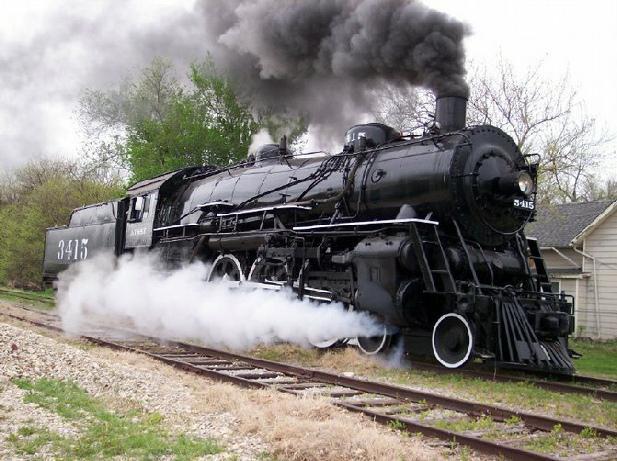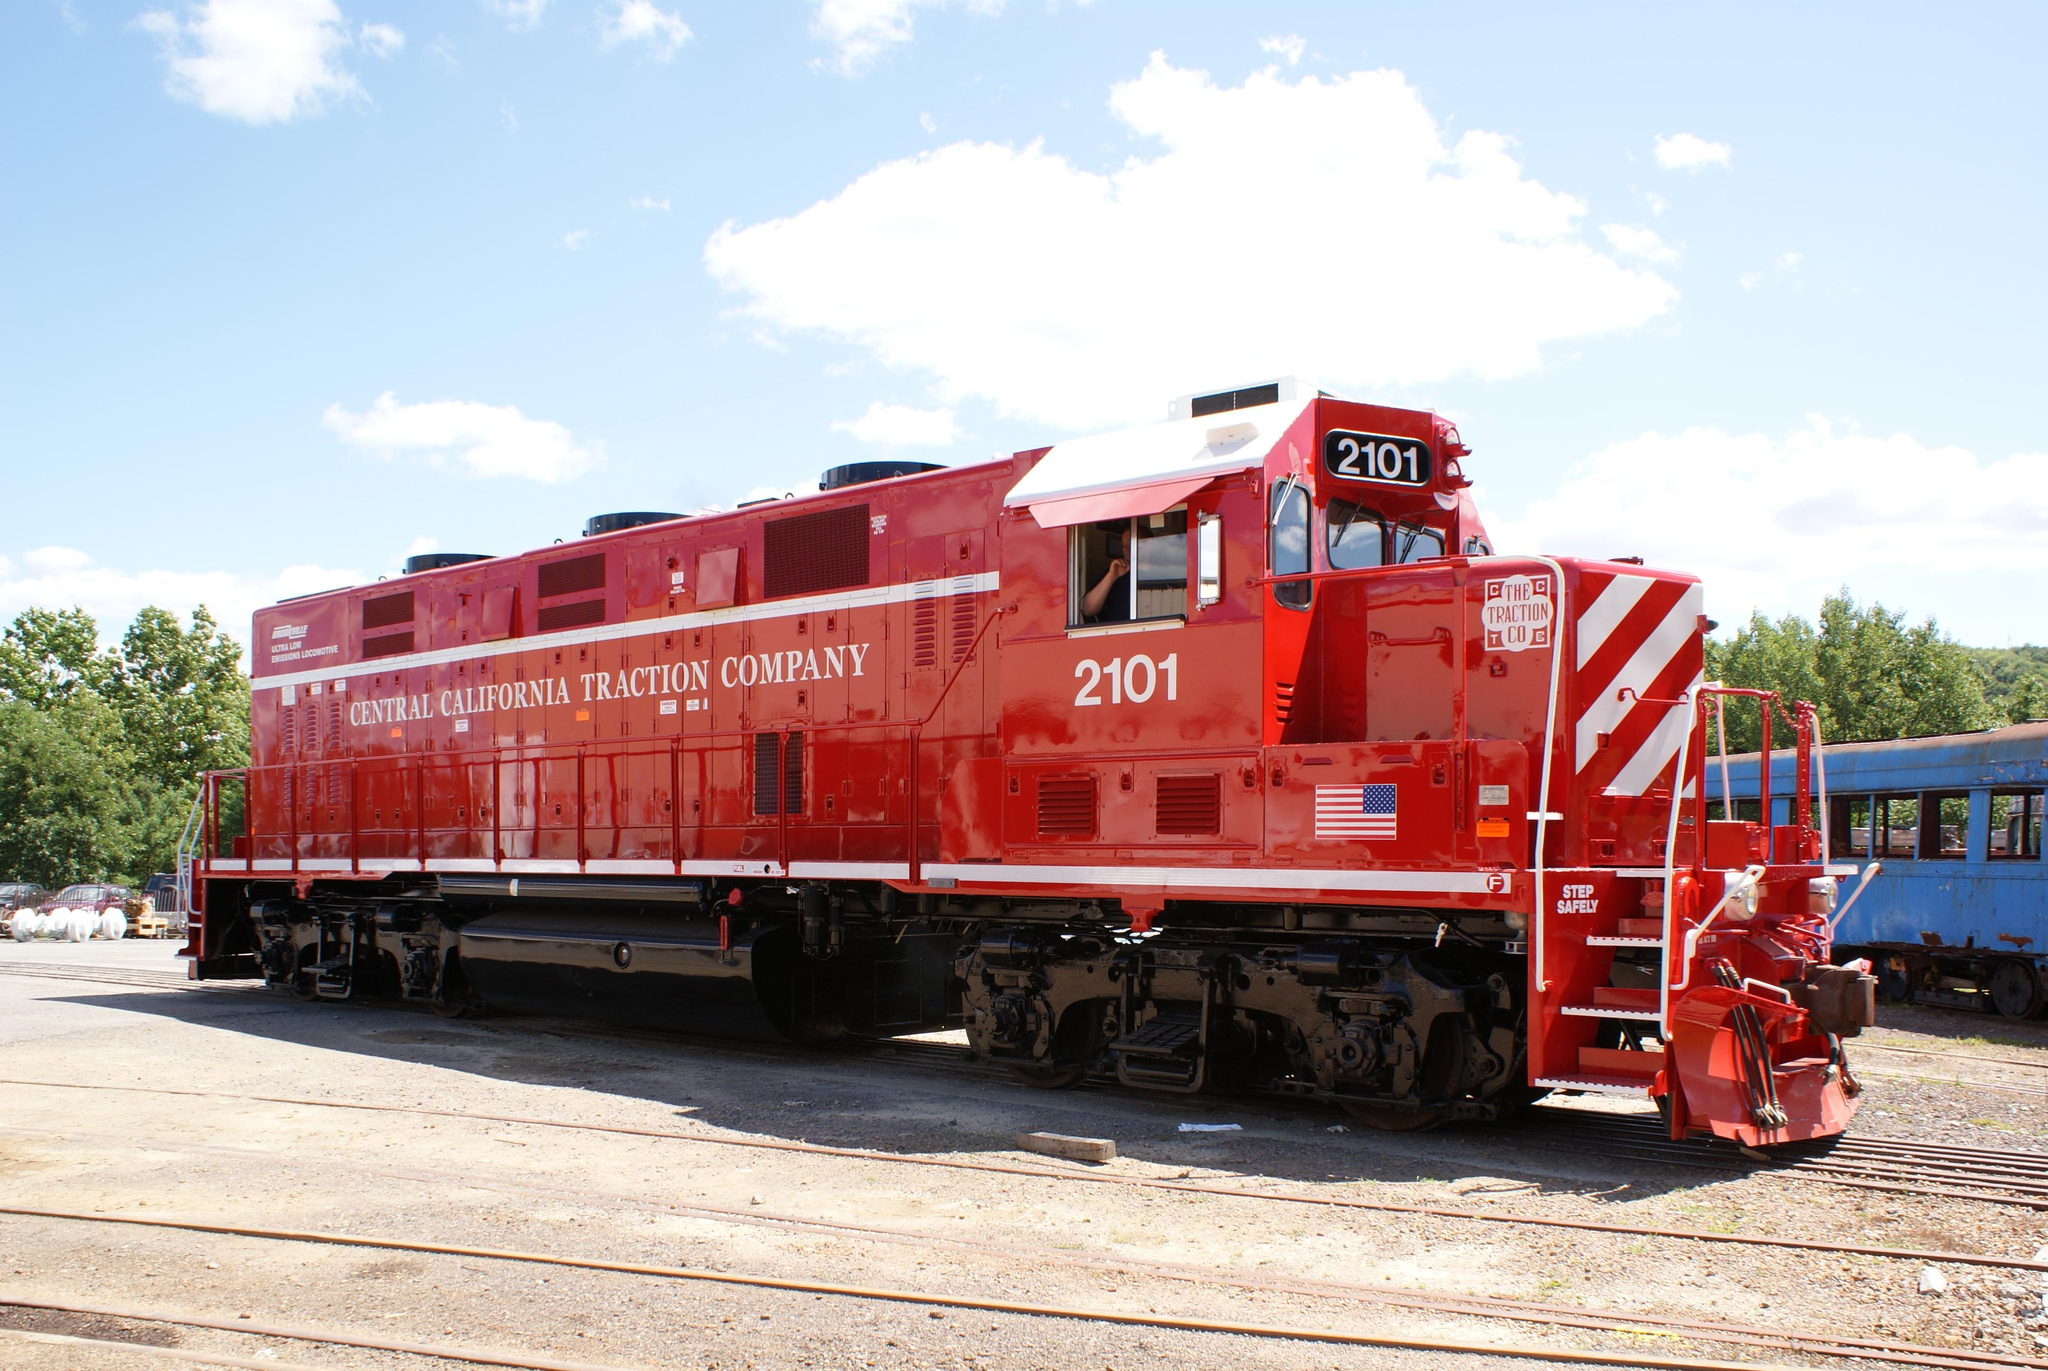The first image is the image on the left, the second image is the image on the right. For the images displayed, is the sentence "The train in the left image is heading towards the left." factually correct? Answer yes or no. No. The first image is the image on the left, the second image is the image on the right. Given the left and right images, does the statement "There are two trains moving towards the right." hold true? Answer yes or no. Yes. 